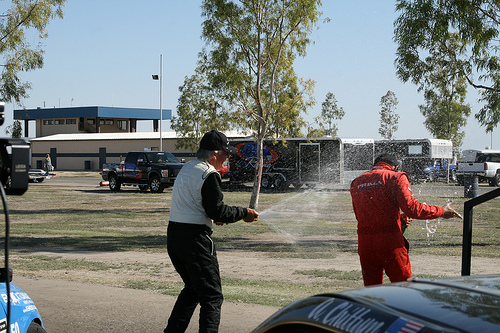<image>
Is there a trailor next to the truck? Yes. The trailor is positioned adjacent to the truck, located nearby in the same general area. 